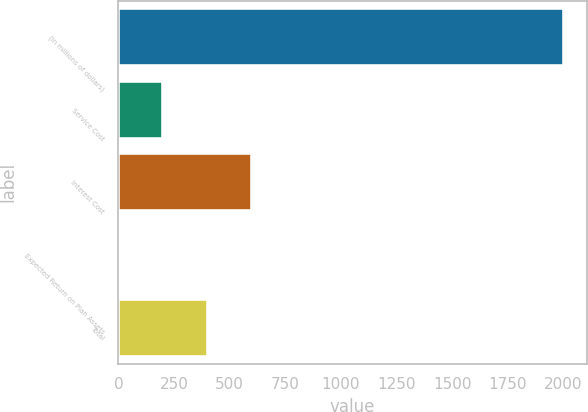Convert chart. <chart><loc_0><loc_0><loc_500><loc_500><bar_chart><fcel>(in millions of dollars)<fcel>Service Cost<fcel>Interest Cost<fcel>Expected Return on Plan Assets<fcel>Total<nl><fcel>2005<fcel>201.13<fcel>601.99<fcel>0.7<fcel>401.56<nl></chart> 